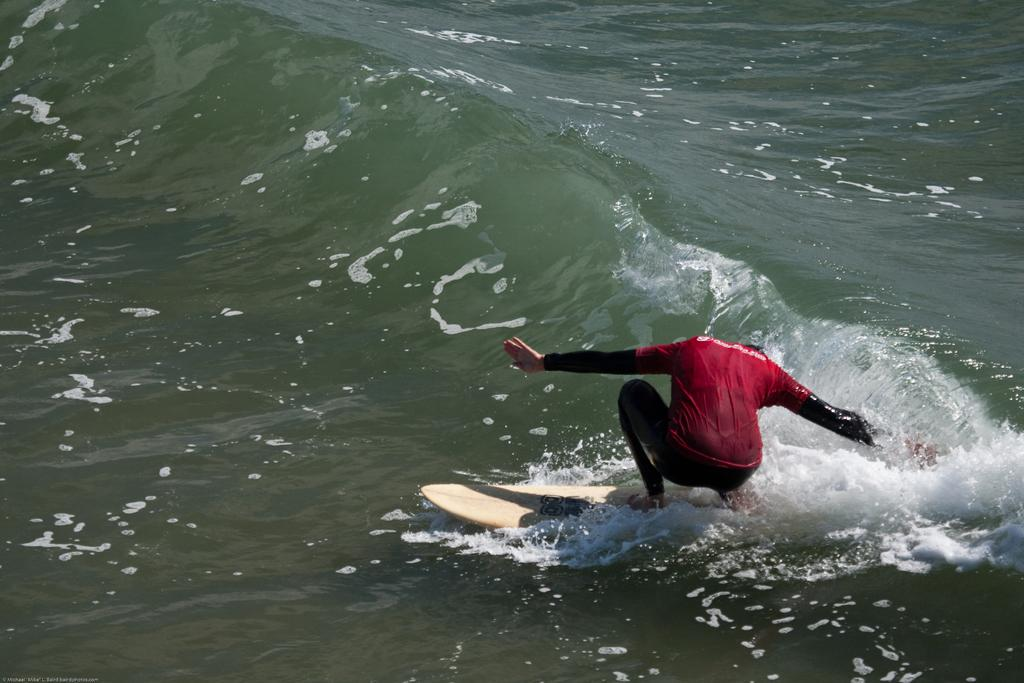What is at the bottom of the image? There is water at the bottom of the image. What activity is the person in the image engaged in? There is a person surfing on the water. What type of crate is being used by the person surfing in the image? There is no crate present in the image; the person is surfing on water. What machine is being used by the person to surf in the image? The person is surfing using a surfboard, not a machine. 